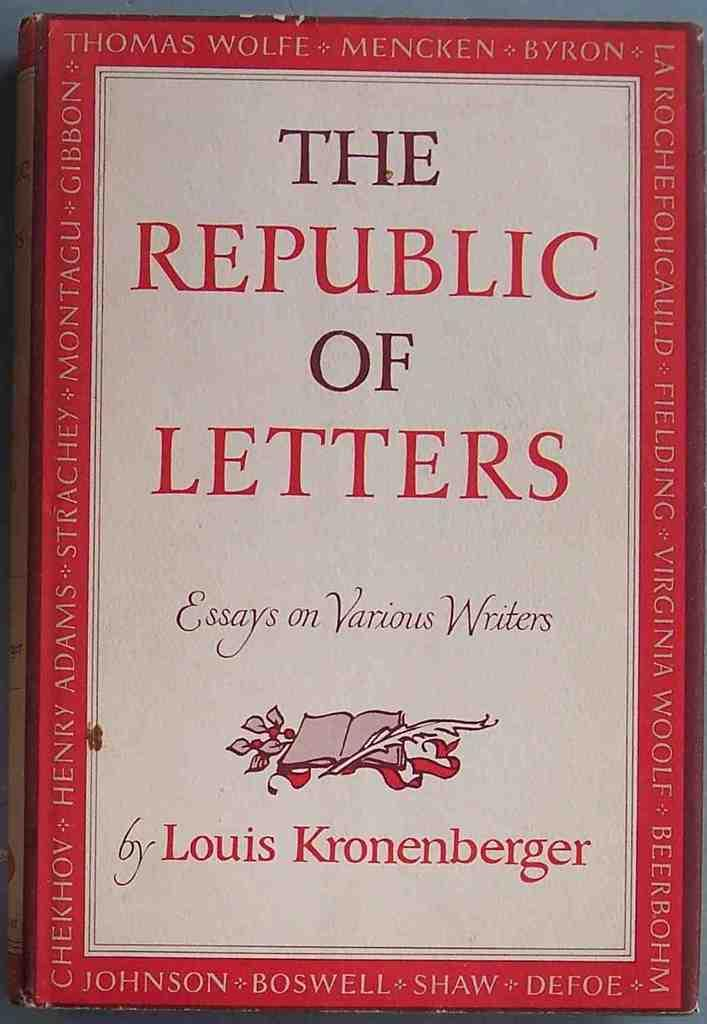<image>
Render a clear and concise summary of the photo. The Republic of Letters hardback book seems to be full of essays from various acclaimed writers from bygone eras. 